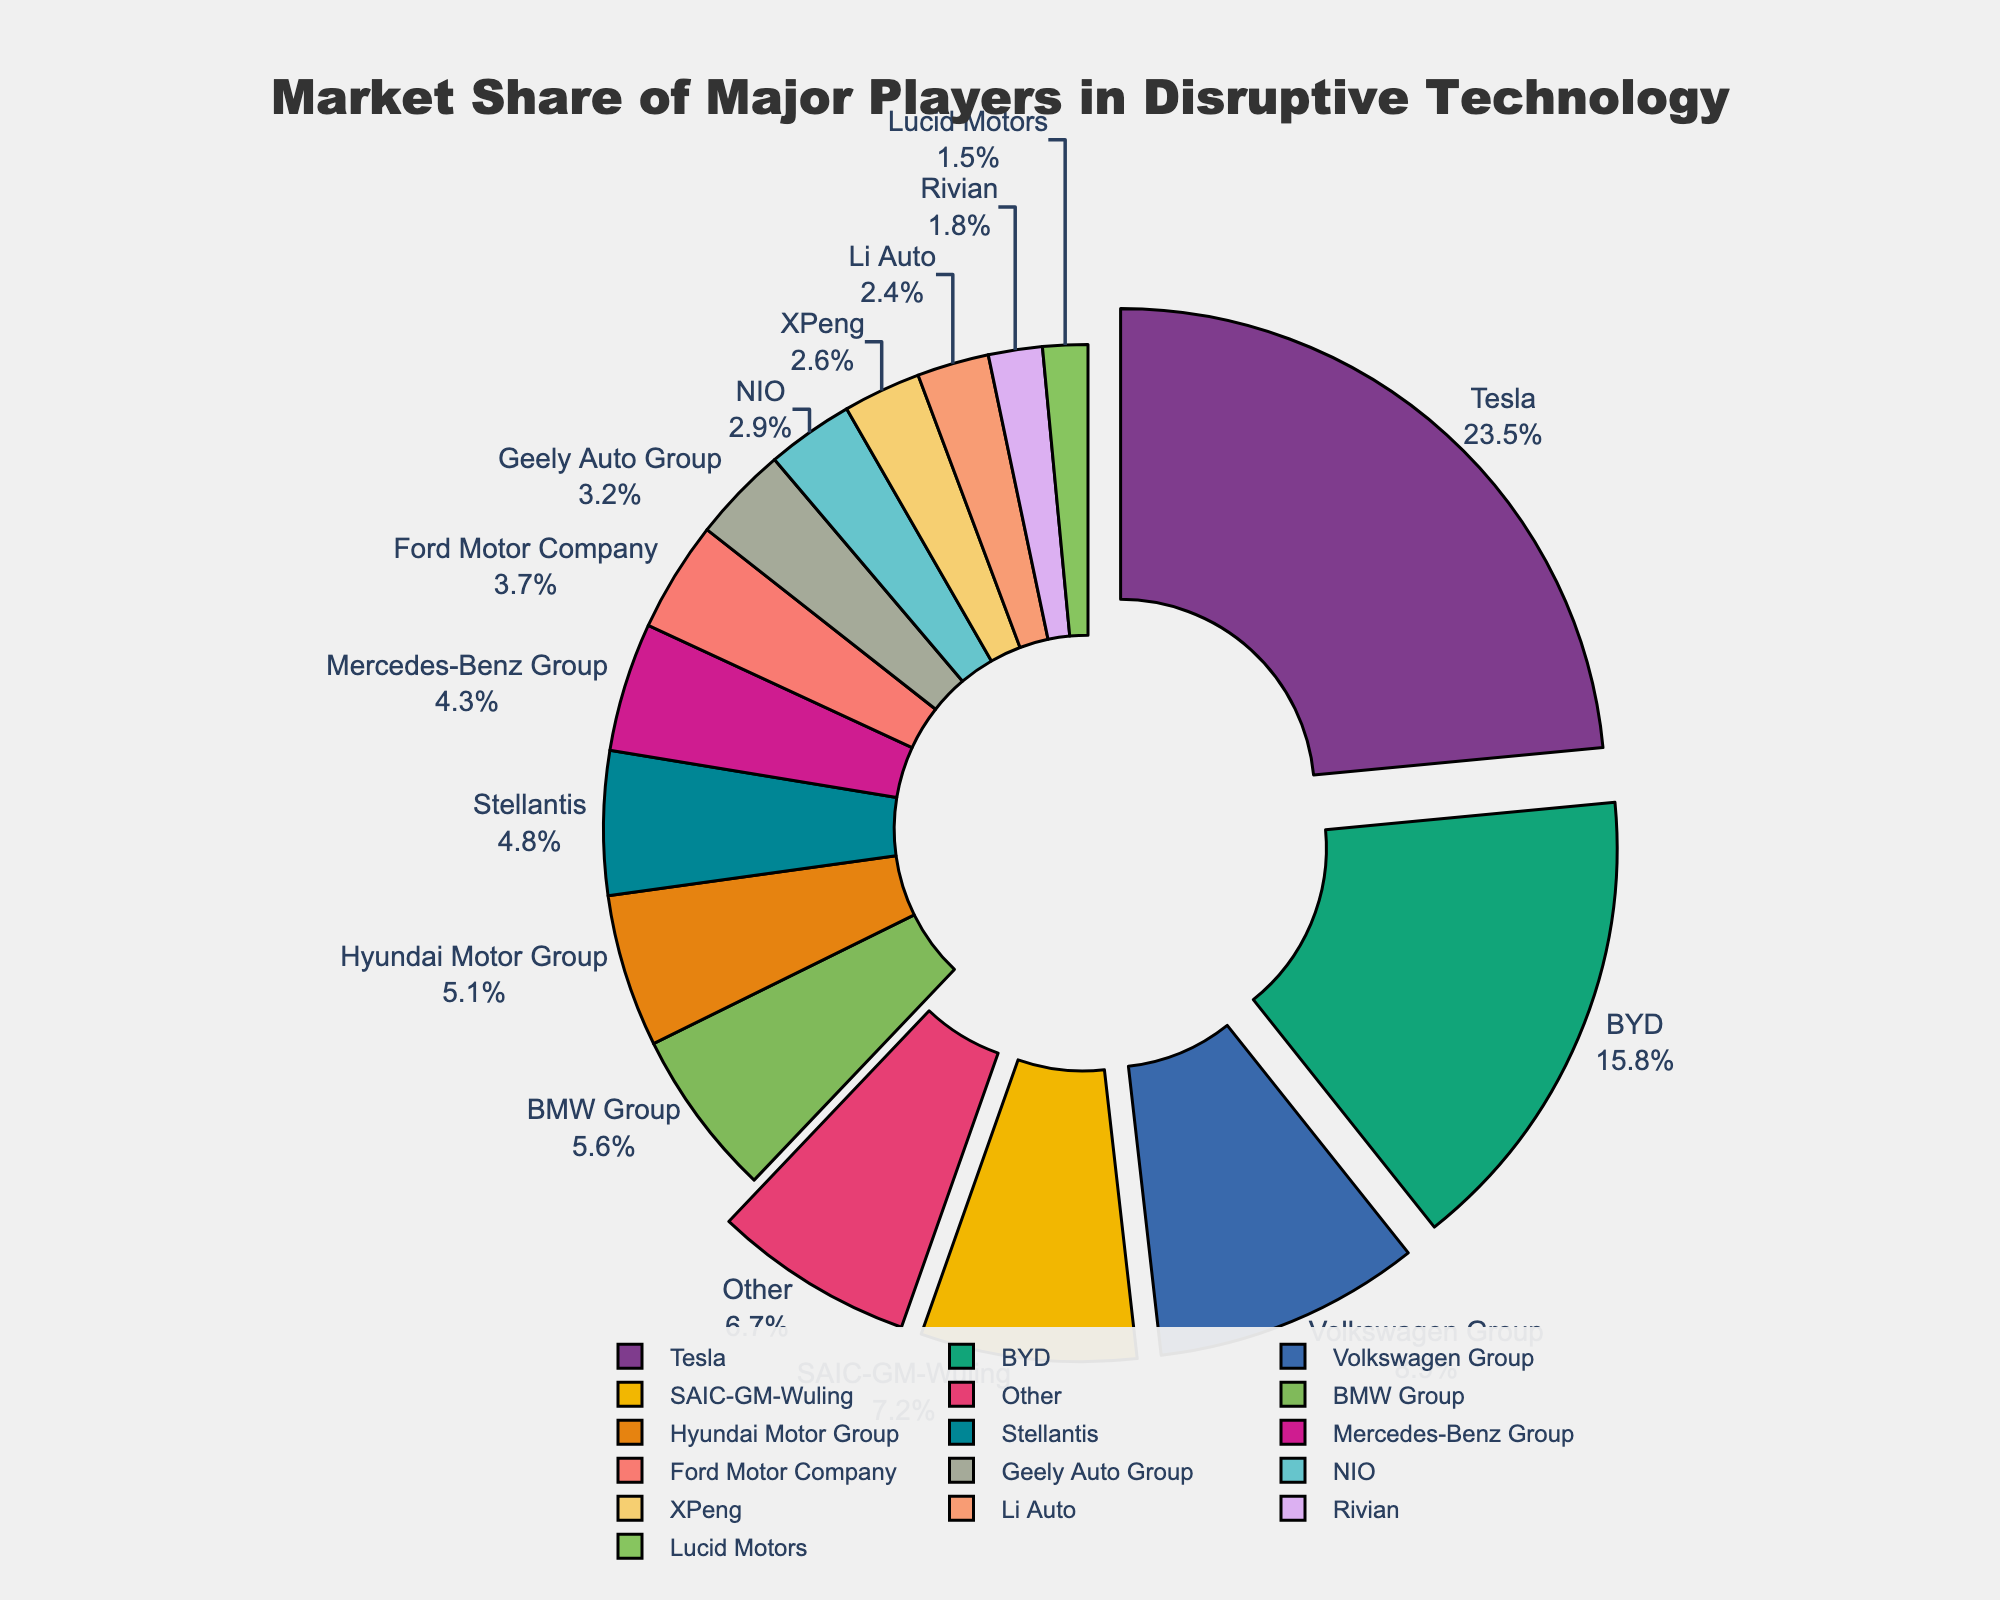Which company has the largest market share? The company with the largest market share will have the biggest slice in the pie chart and will be labeled with the highest percentage. In the chart, Tesla has the largest market share with 23.5%.
Answer: Tesla What is the combined market share of Tesla, BYD, and Volkswagen Group? Sum up the market share percentages of Tesla (23.5%), BYD (15.8%), and Volkswagen Group (8.9%). 23.5 + 15.8 + 8.9 = 48.2%.
Answer: 48.2% How does the market share of NIO compare with XPeng? Compare the market share percentages of NIO (2.9%) and XPeng (2.6%) by looking at their respective slices in the pie chart. NIO has a slightly higher market share than XPeng.
Answer: NIO has a higher market share Which company's market share percentage is closest to Ford Motor Company? Look at the market share percentages around Ford Motor Company (3.7%). Geely Auto Group's market share (3.2%) is the closest.
Answer: Geely Auto Group What is the total market share percentage of companies with less than a 5% share? Sum up the market shares of BMW Group (5.6%), Hyundai Motor Group (5.1%), Stellantis (4.8%), Mercedes-Benz Group (4.3%), Ford Motor Company (3.7%), Geely Auto Group (3.2%), NIO (2.9%), XPeng (2.6%), Li Auto (2.4%), Rivian (1.8%), Lucid Motors (1.5%), and Other (6.7%). 3.7 + 3.2 + 2.9 + 2.6 + 2.4 + 1.8 + 1.5 + 6.7 = 24.8%.
Answer: 24.8% Which companies have their slices pulled out in the pie chart? The pie chart pulls out the slices for the top 5 companies. These are Tesla, BYD, Volkswagen Group, SAIC-GM-Wuling, and BMW Group.
Answer: Tesla, BYD, Volkswagen Group, SAIC-GM-Wuling, and BMW Group What is the difference in market share between the largest player (Tesla) and the smallest named player (Lucid Motors)? Subtract Lucid Motors' market share (1.5%) from Tesla's market share (23.5%). 23.5 - 1.5 = 22%.
Answer: 22% What percentage of the market is held by companies other than the top 5 players? Subtract the combined market share of the top 5 companies (Tesla, BYD, Volkswagen Group, SAIC-GM-Wuling, and BMW Group) from 100%. The combined market share is 23.5 + 15.8 + 8.9 + 7.2 + 5.6 = 61%. 100 - 61 = 39%.
Answer: 39% Which company has a market share that is approximately half of Volkswagen Group's share? Volkswagen Group's market share is 8.9%. Approximately half of 8.9% is around 4.45%. Among the companies listed, Stellantis has a market share close to this value at 4.8%.
Answer: Stellantis What is the average market share of the companies listed (excluding 'Other')? Add up all the market shares of the listed companies and divide by the number of companies. The sum of the shares is 100 - 6.7 (Other) = 93.3. There are 15 companies listed. 93.3 / 15 = 6.22%.
Answer: 6.22% 